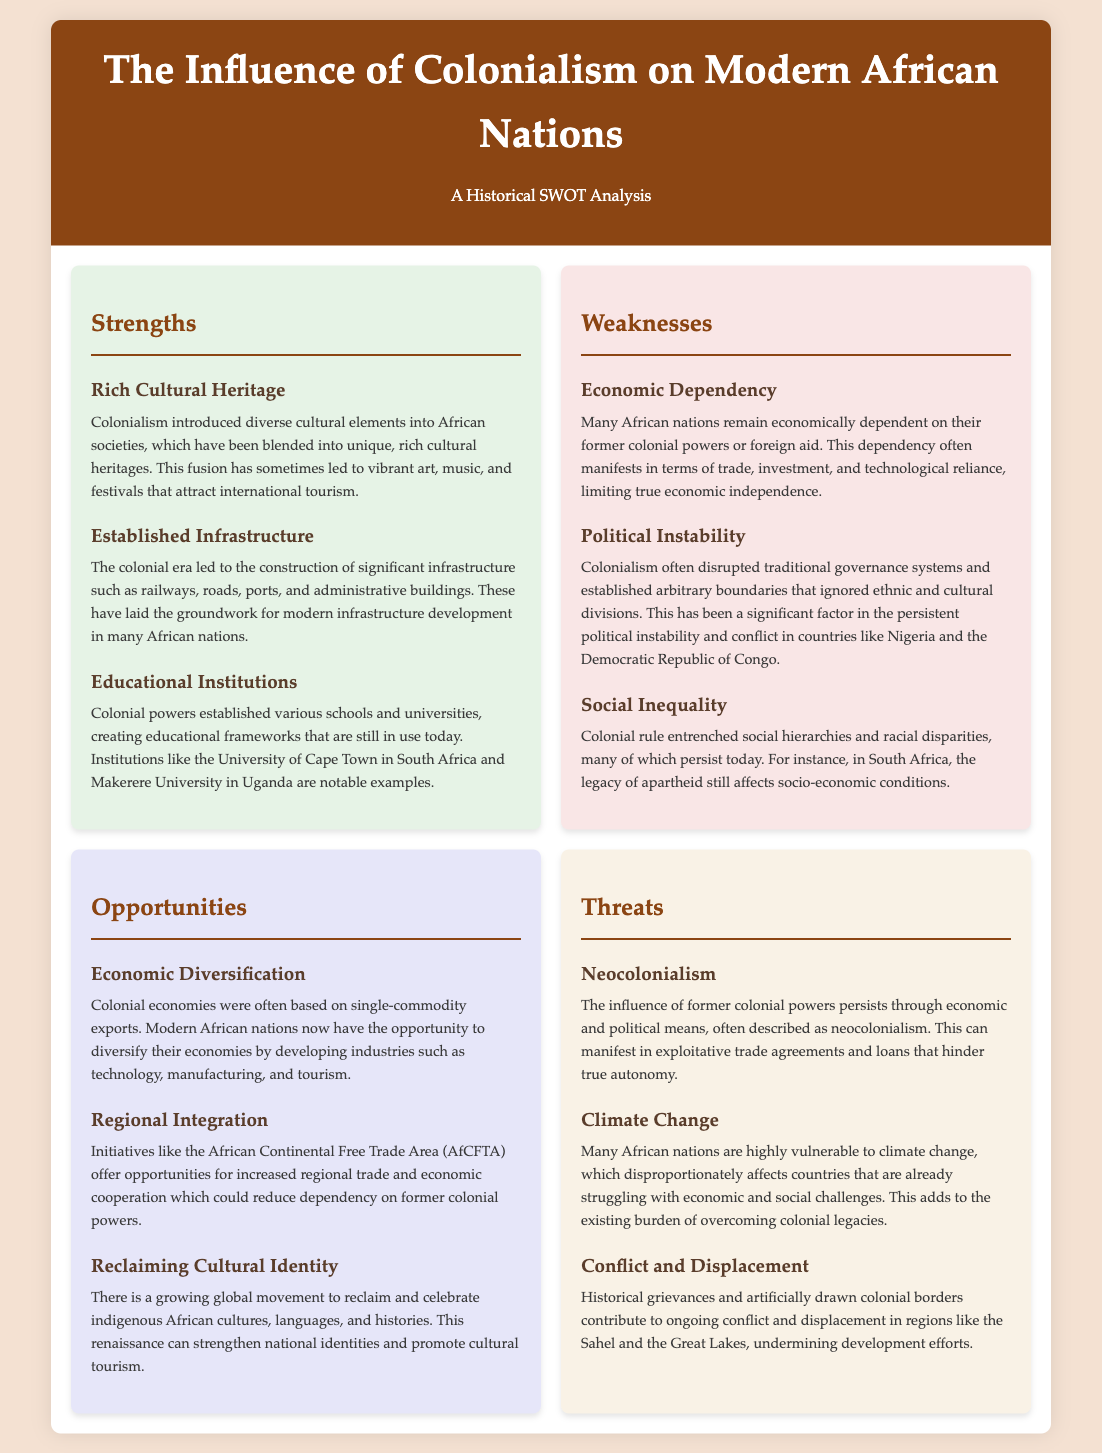What are three strengths mentioned? The strengths listed include Rich Cultural Heritage, Established Infrastructure, and Educational Institutions.
Answer: Rich Cultural Heritage, Established Infrastructure, Educational Institutions What social issue persists in South Africa due to colonialism? The document indicates that the legacy of apartheid affects socio-economic conditions in South Africa.
Answer: Apartheid What is a major threat related to economic influence? Neocolonialism is described as a major threat due to the influence of former colonial powers.
Answer: Neocolonialism Which movement provides an opportunity for cultural celebration? The movement to reclaim and celebrate indigenous African cultures is mentioned as an opportunity.
Answer: Reclaiming Cultural Identity Which two countries are highlighted as examples of political instability? Nigeria and the Democratic Republic of Congo are specified as examples of political instability due to colonialism.
Answer: Nigeria, Democratic Republic of Congo What critical issue is exacerbated by climate change? The document states that climate change adds to the existing burden of overcoming colonial legacies.
Answer: Existing burden What organization promotes regional trade among African nations? The African Continental Free Trade Area (AfCFTA) is mentioned as promoting regional trade and cooperation.
Answer: African Continental Free Trade Area What kind of economic development opportunity is mentioned? Economic diversification is described as an opportunity for developing various industries.
Answer: Economic Diversification How is colonialism related to conflict in modern Africa? The document notes that historical grievances from colonialism contribute to ongoing conflict in certain regions.
Answer: Ongoing conflict 